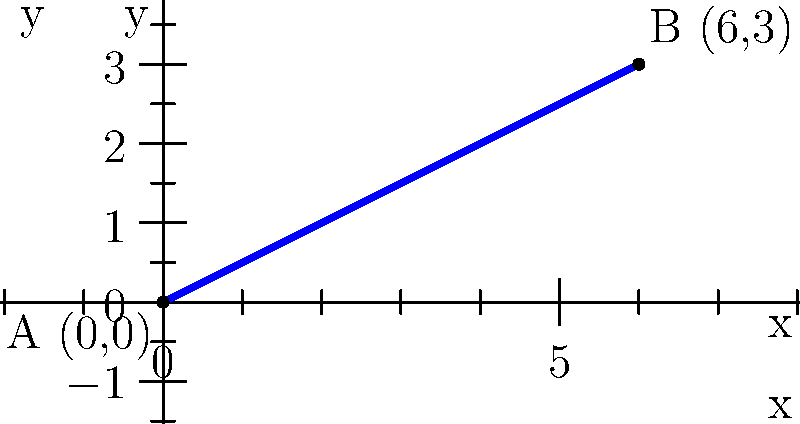As you prepare for your next ski jumping competition, you're analyzing the ramp's slope. The starting point A is at (0,0), and the end point B is at (6,3) on a coordinate plane where each unit represents 10 meters. Calculate the slope of the ski jump ramp. To find the slope of the ski jump ramp, we'll use the slope formula:

$$ \text{slope} = m = \frac{y_2 - y_1}{x_2 - x_1} $$

Where $(x_1, y_1)$ is the first point and $(x_2, y_2)$ is the second point.

Step 1: Identify the coordinates of points A and B.
Point A: $(0, 0)$
Point B: $(6, 3)$

Step 2: Plug these values into the slope formula.
$$ m = \frac{y_2 - y_1}{x_2 - x_1} = \frac{3 - 0}{6 - 0} = \frac{3}{6} $$

Step 3: Simplify the fraction.
$$ m = \frac{3}{6} = \frac{1}{2} = 0.5 $$

Therefore, the slope of the ski jump ramp is $\frac{1}{2}$ or 0.5.

Note: This means for every 10 meters of horizontal distance (1 unit on the x-axis), the ramp rises 5 meters (0.5 units on the y-axis).
Answer: $\frac{1}{2}$ or 0.5 